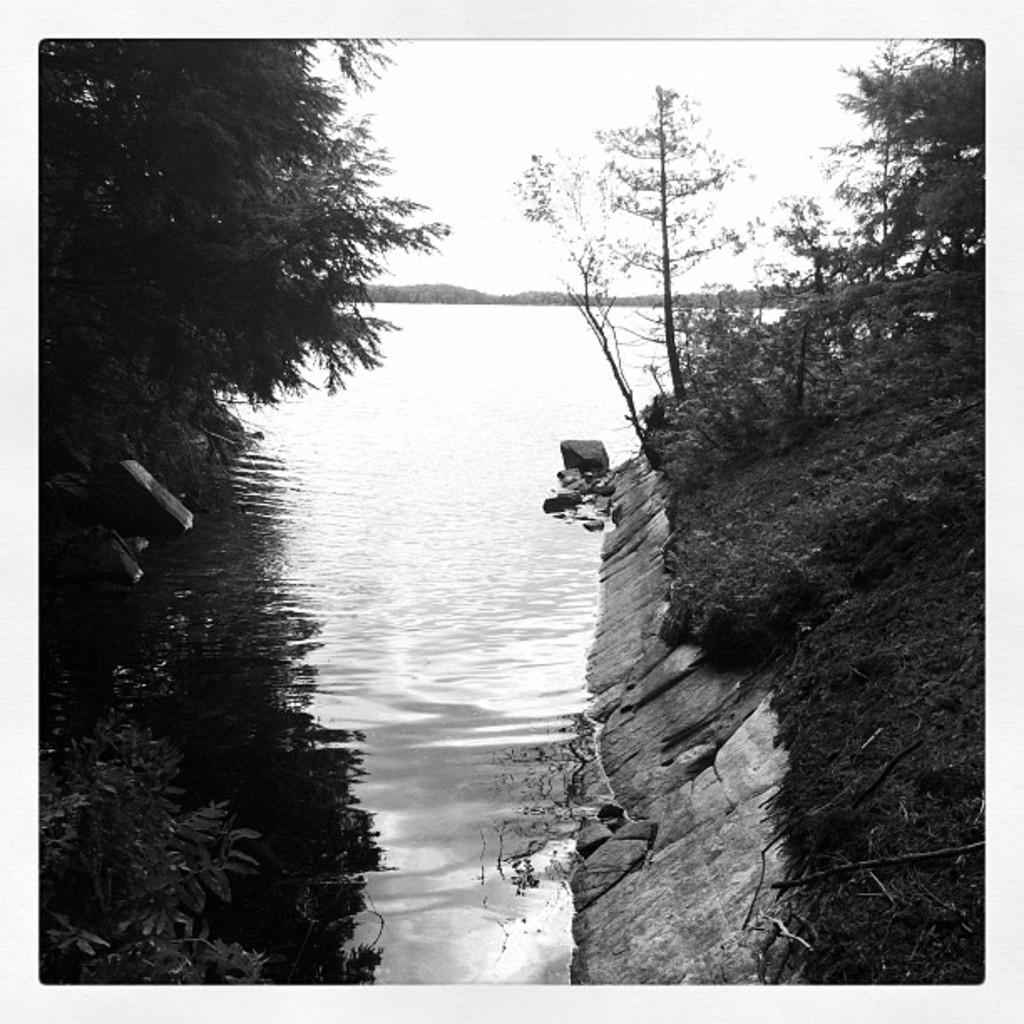What type of natural environment is depicted in the image? The image features many trees, rocks, and water, suggesting a natural landscape. Can you describe the water in the image? The water is visible in the image, but its specific characteristics are not mentioned in the facts. What is visible in the background of the image? The sky is visible in the background of the image. How many owls can be seen sitting on the rocks in the image? There are no owls present in the image; it features trees, rocks, and water. 